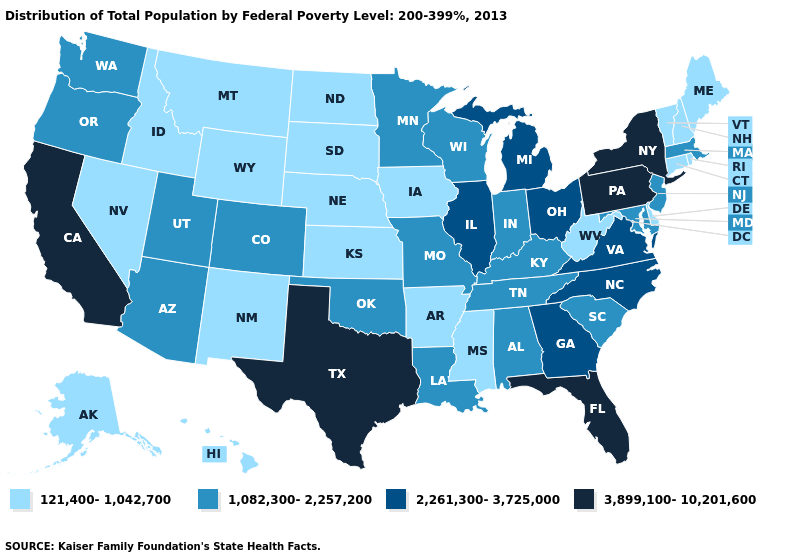Among the states that border West Virginia , which have the lowest value?
Be succinct. Kentucky, Maryland. Name the states that have a value in the range 3,899,100-10,201,600?
Give a very brief answer. California, Florida, New York, Pennsylvania, Texas. Does Michigan have the highest value in the MidWest?
Be succinct. Yes. Which states have the highest value in the USA?
Give a very brief answer. California, Florida, New York, Pennsylvania, Texas. What is the highest value in the Northeast ?
Answer briefly. 3,899,100-10,201,600. Among the states that border Idaho , which have the lowest value?
Keep it brief. Montana, Nevada, Wyoming. Name the states that have a value in the range 121,400-1,042,700?
Keep it brief. Alaska, Arkansas, Connecticut, Delaware, Hawaii, Idaho, Iowa, Kansas, Maine, Mississippi, Montana, Nebraska, Nevada, New Hampshire, New Mexico, North Dakota, Rhode Island, South Dakota, Vermont, West Virginia, Wyoming. What is the value of Iowa?
Quick response, please. 121,400-1,042,700. How many symbols are there in the legend?
Write a very short answer. 4. What is the highest value in the MidWest ?
Concise answer only. 2,261,300-3,725,000. What is the value of Alaska?
Write a very short answer. 121,400-1,042,700. Does Washington have a higher value than North Dakota?
Short answer required. Yes. Which states have the lowest value in the MidWest?
Be succinct. Iowa, Kansas, Nebraska, North Dakota, South Dakota. Name the states that have a value in the range 121,400-1,042,700?
Write a very short answer. Alaska, Arkansas, Connecticut, Delaware, Hawaii, Idaho, Iowa, Kansas, Maine, Mississippi, Montana, Nebraska, Nevada, New Hampshire, New Mexico, North Dakota, Rhode Island, South Dakota, Vermont, West Virginia, Wyoming. Which states have the lowest value in the MidWest?
Give a very brief answer. Iowa, Kansas, Nebraska, North Dakota, South Dakota. 